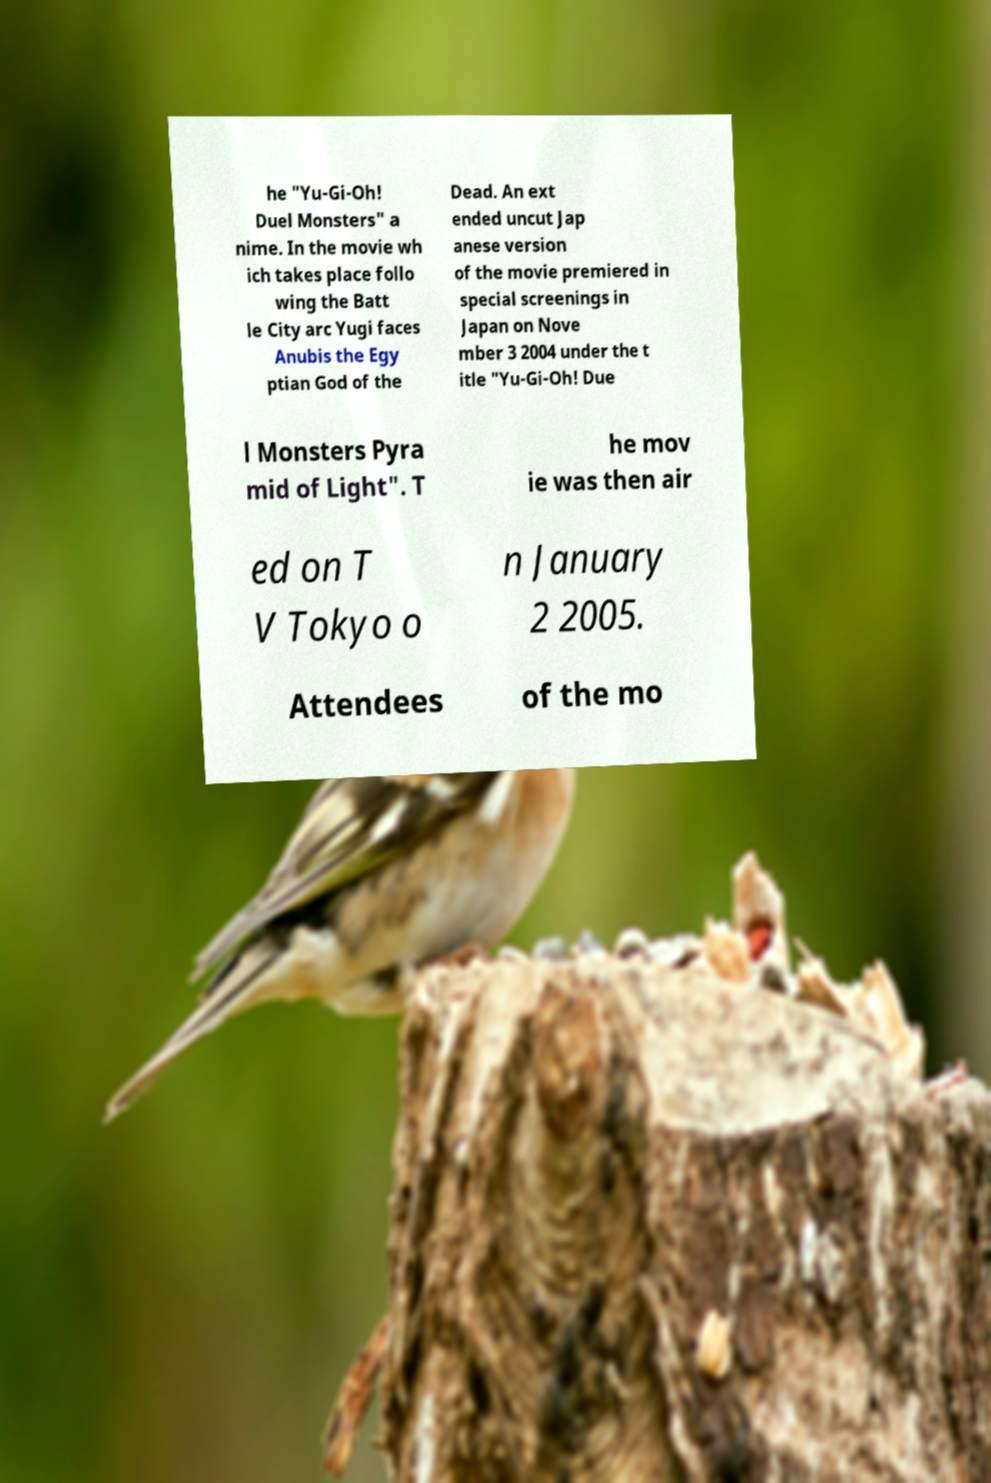Could you assist in decoding the text presented in this image and type it out clearly? he "Yu-Gi-Oh! Duel Monsters" a nime. In the movie wh ich takes place follo wing the Batt le City arc Yugi faces Anubis the Egy ptian God of the Dead. An ext ended uncut Jap anese version of the movie premiered in special screenings in Japan on Nove mber 3 2004 under the t itle "Yu-Gi-Oh! Due l Monsters Pyra mid of Light". T he mov ie was then air ed on T V Tokyo o n January 2 2005. Attendees of the mo 